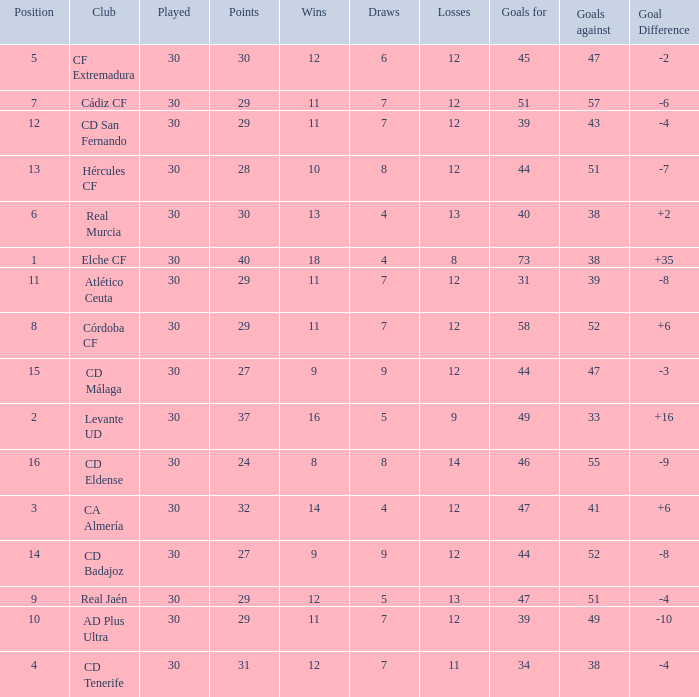What is the number of goals with less than 14 wins and a goal difference less than -4? 51, 39, 31, 44, 44, 46. 